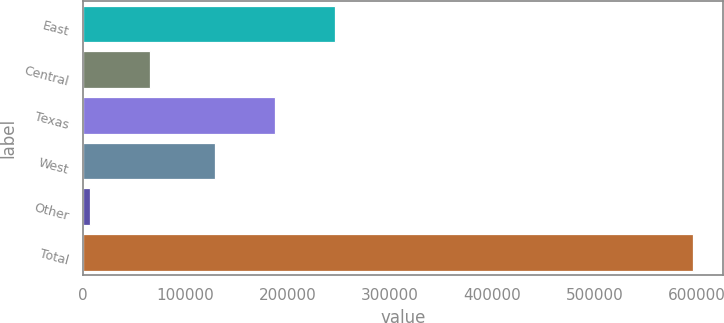<chart> <loc_0><loc_0><loc_500><loc_500><bar_chart><fcel>East<fcel>Central<fcel>Texas<fcel>West<fcel>Other<fcel>Total<nl><fcel>246750<fcel>65349.4<fcel>187755<fcel>128761<fcel>6355<fcel>596299<nl></chart> 